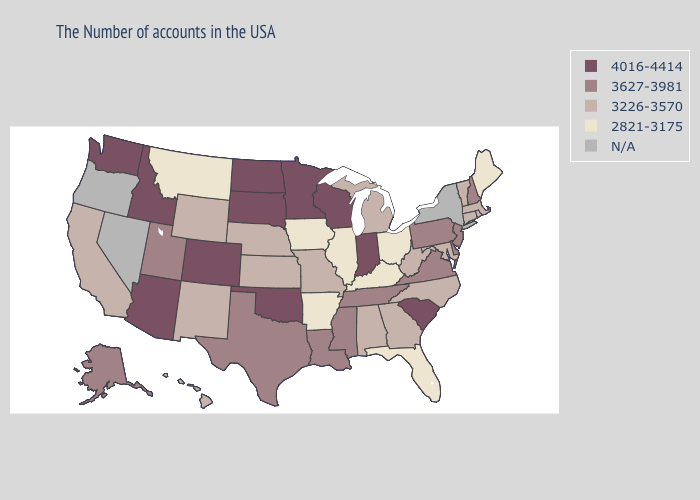Name the states that have a value in the range 3627-3981?
Be succinct. New Hampshire, New Jersey, Delaware, Pennsylvania, Virginia, Tennessee, Mississippi, Louisiana, Texas, Utah, Alaska. Which states have the highest value in the USA?
Answer briefly. South Carolina, Indiana, Wisconsin, Minnesota, Oklahoma, South Dakota, North Dakota, Colorado, Arizona, Idaho, Washington. What is the value of Massachusetts?
Write a very short answer. 3226-3570. Does the first symbol in the legend represent the smallest category?
Be succinct. No. Among the states that border Vermont , which have the lowest value?
Concise answer only. Massachusetts. Which states have the highest value in the USA?
Keep it brief. South Carolina, Indiana, Wisconsin, Minnesota, Oklahoma, South Dakota, North Dakota, Colorado, Arizona, Idaho, Washington. What is the value of Idaho?
Keep it brief. 4016-4414. Which states hav the highest value in the Northeast?
Short answer required. New Hampshire, New Jersey, Pennsylvania. Name the states that have a value in the range N/A?
Be succinct. New York, Nevada, Oregon. Among the states that border Kentucky , does Virginia have the highest value?
Answer briefly. No. What is the value of Kentucky?
Write a very short answer. 2821-3175. Name the states that have a value in the range 3226-3570?
Keep it brief. Massachusetts, Rhode Island, Vermont, Connecticut, Maryland, North Carolina, West Virginia, Georgia, Michigan, Alabama, Missouri, Kansas, Nebraska, Wyoming, New Mexico, California, Hawaii. What is the value of California?
Answer briefly. 3226-3570. 